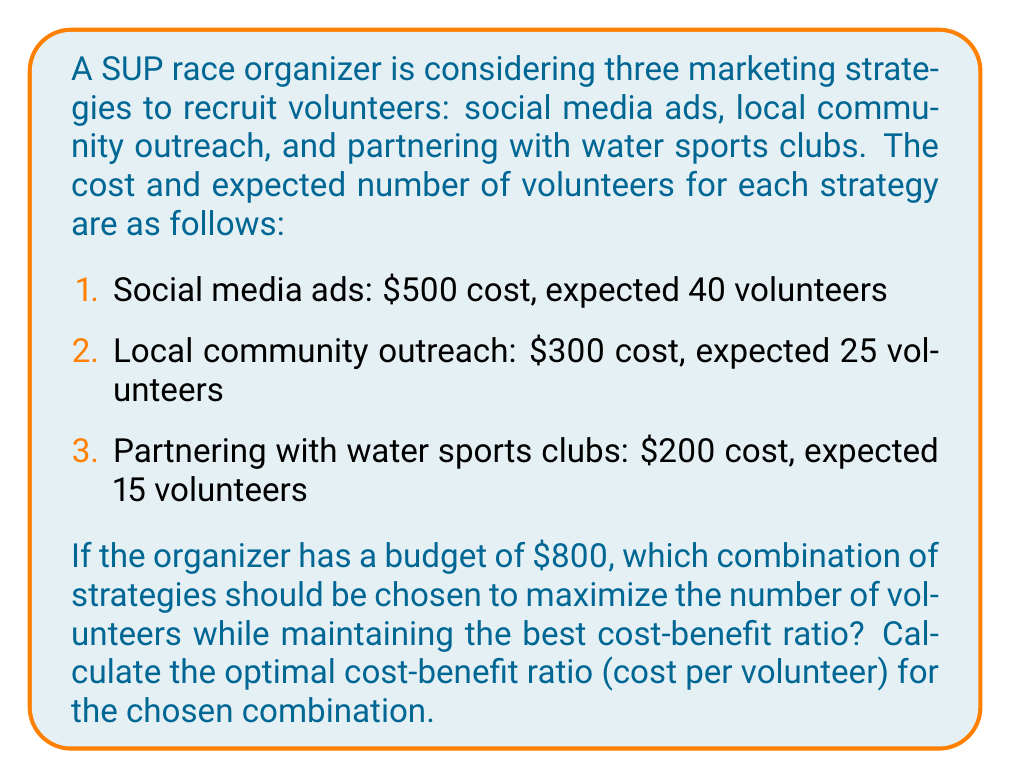Can you answer this question? To solve this problem, we need to follow these steps:

1. Calculate the cost-benefit ratio (cost per volunteer) for each strategy:
   
   Social media ads: $\frac{500}{40} = $12.50 per volunteer
   Local community outreach: $\frac{300}{25} = $12.00 per volunteer
   Partnering with water sports clubs: $\frac{200}{15} = $13.33 per volunteer

2. Rank the strategies from best (lowest cost per volunteer) to worst:
   1. Local community outreach
   2. Social media ads
   3. Partnering with water sports clubs

3. Allocate the budget to the best strategies first:
   - Start with local community outreach: $300
   - Remaining budget: $800 - $300 = $500
   - Next, choose social media ads: $500
   - Total spent: $300 + $500 = $800 (budget fully utilized)

4. Calculate the total number of volunteers:
   Local community outreach: 25 volunteers
   Social media ads: 40 volunteers
   Total: 25 + 40 = 65 volunteers

5. Calculate the overall cost-benefit ratio:
   $$\text{Cost-benefit ratio} = \frac{\text{Total cost}}{\text{Total volunteers}} = \frac{800}{65} = $12.31 \text{ per volunteer}$$

This combination of strategies (local community outreach and social media ads) maximizes the number of volunteers while maintaining the best overall cost-benefit ratio within the given budget.
Answer: The optimal combination is local community outreach and social media ads, with a cost-benefit ratio of $12.31 per volunteer. 